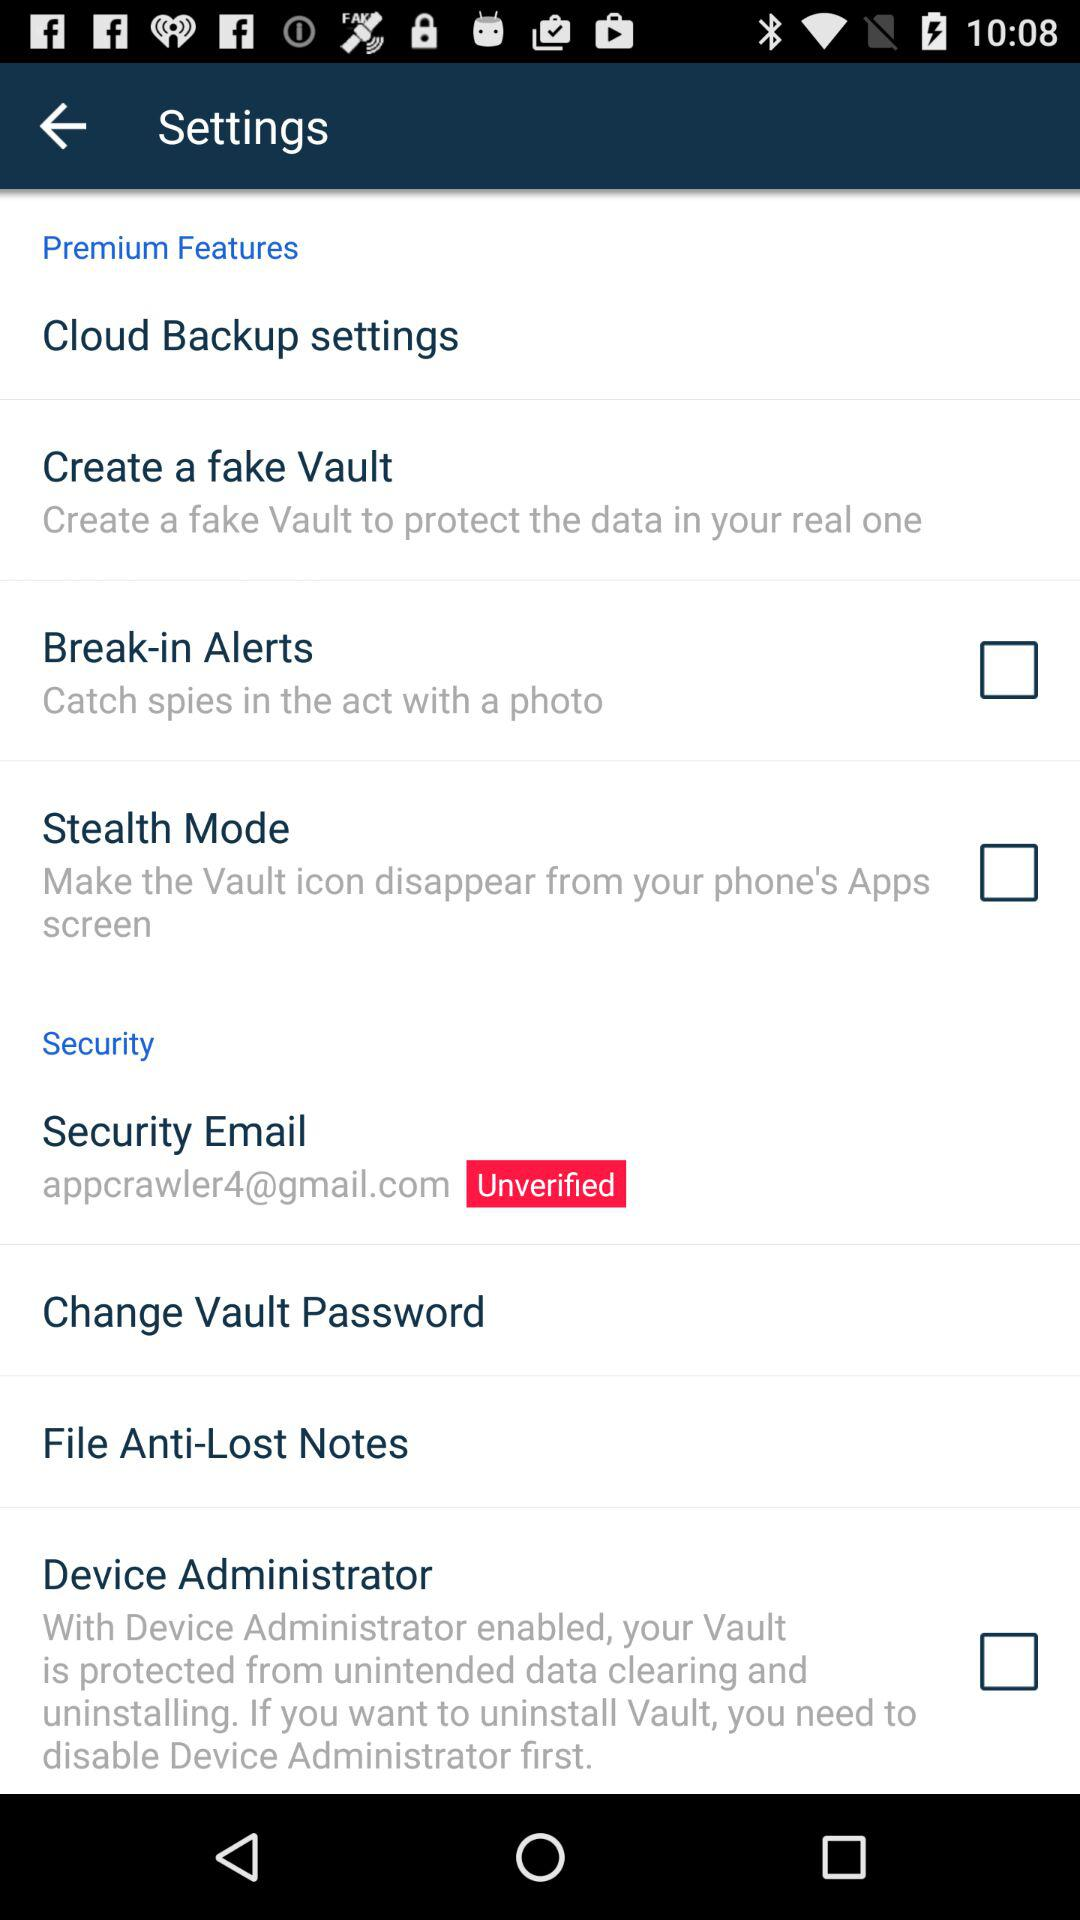What is the email address? The email address is appcrawler4@gmail.com. 